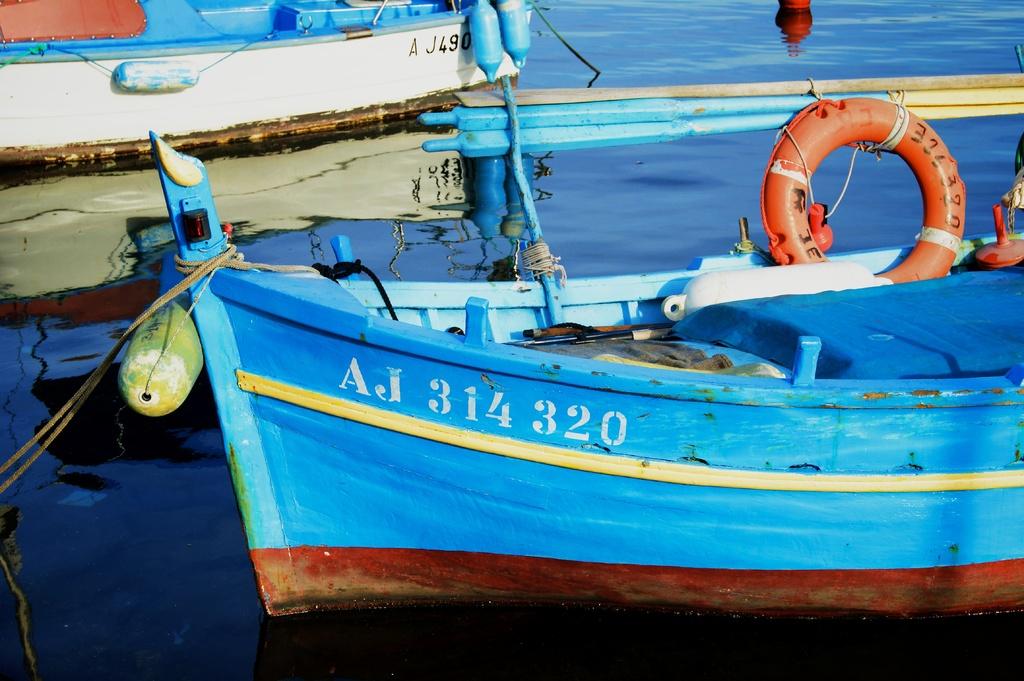What is the model number of the boat?
Offer a very short reply. Aj 314 320. 